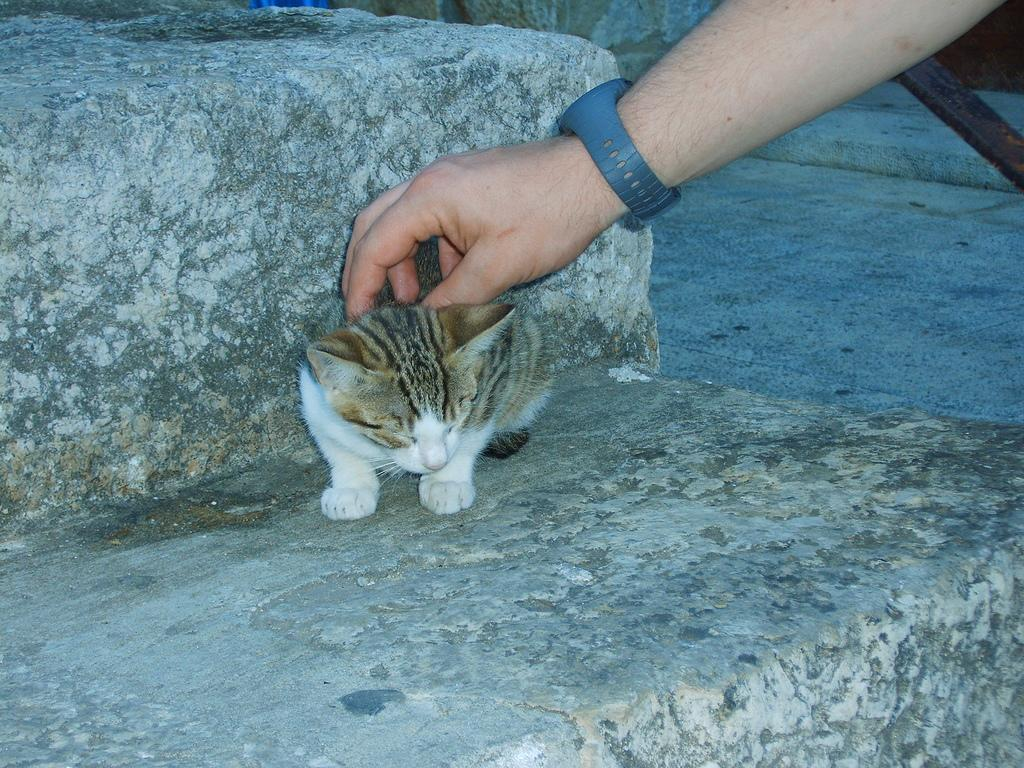What animal is sitting on a rock in the image? There is a cat sitting on a rock in the image. What is the person in the image doing with the cat? The person is touching the cat in the image. What accessory is the person wearing? The person is wearing a watch. What can be seen on the right side of the image? There is a floor visible on the right side of the image. What type of wine is being poured into the can in the image? There is no wine or can present in the image; it features a cat sitting on a rock and a person touching the cat. How many lizards are crawling on the floor in the image? There are no lizards present in the image; it only shows a cat, a person, and a floor. 